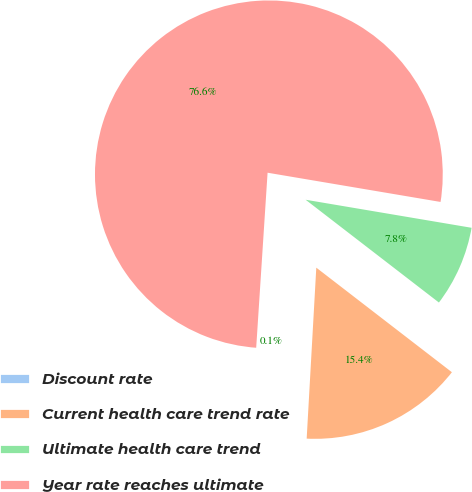Convert chart to OTSL. <chart><loc_0><loc_0><loc_500><loc_500><pie_chart><fcel>Discount rate<fcel>Current health care trend rate<fcel>Ultimate health care trend<fcel>Year rate reaches ultimate<nl><fcel>0.14%<fcel>15.44%<fcel>7.79%<fcel>76.63%<nl></chart> 